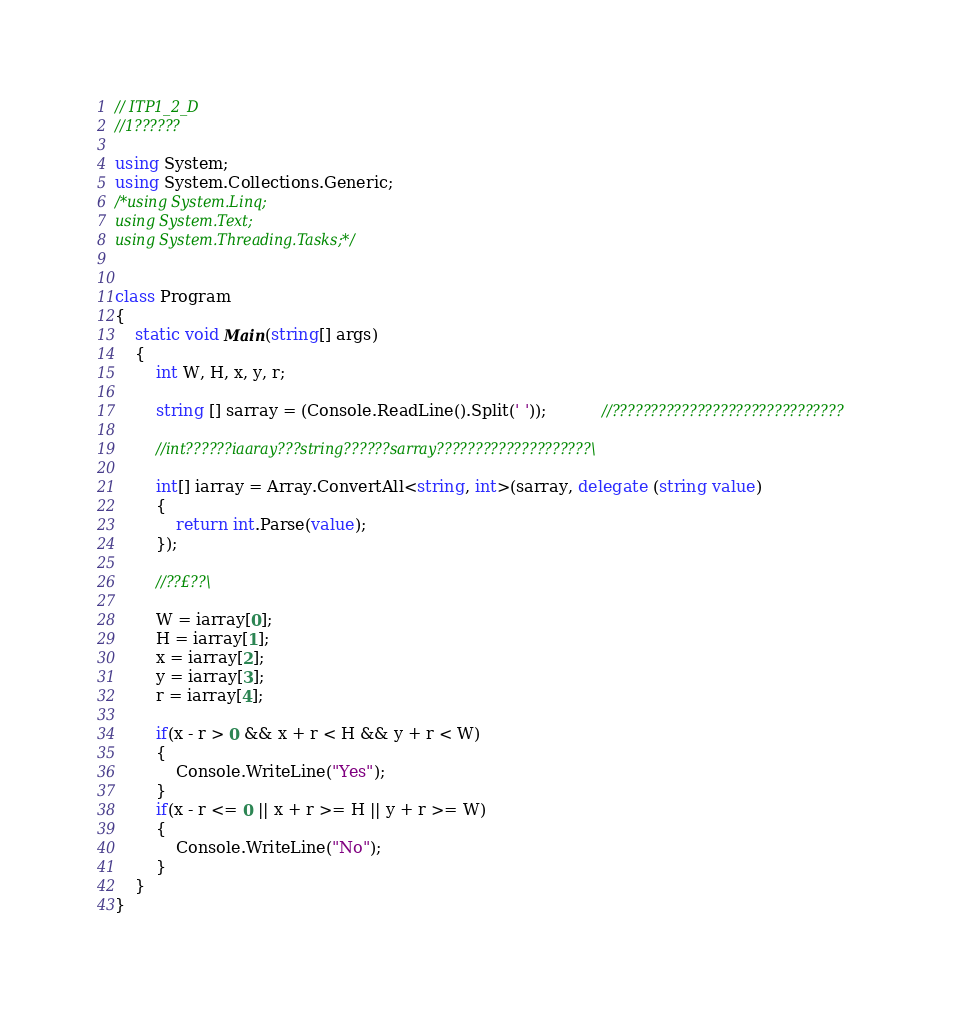<code> <loc_0><loc_0><loc_500><loc_500><_C#_>// ITP1_2_D 
//1??????

using System;
using System.Collections.Generic;
/*using System.Linq;
using System.Text;
using System.Threading.Tasks;*/


class Program
{
    static void Main(string[] args)
    {
        int W, H, x, y, r;

        string [] sarray = (Console.ReadLine().Split(' '));           //??????????????????????????????

        //int??????iaaray???string??????sarray????????????????????\

        int[] iarray = Array.ConvertAll<string, int>(sarray, delegate (string value)
        {
            return int.Parse(value);
        });

        //??£??\

        W = iarray[0];
        H = iarray[1];
        x = iarray[2];
        y = iarray[3];
        r = iarray[4];

        if(x - r > 0 && x + r < H && y + r < W)
        {
            Console.WriteLine("Yes");
        }
        if(x - r <= 0 || x + r >= H || y + r >= W)
        {
            Console.WriteLine("No");
        }
    }
}</code> 